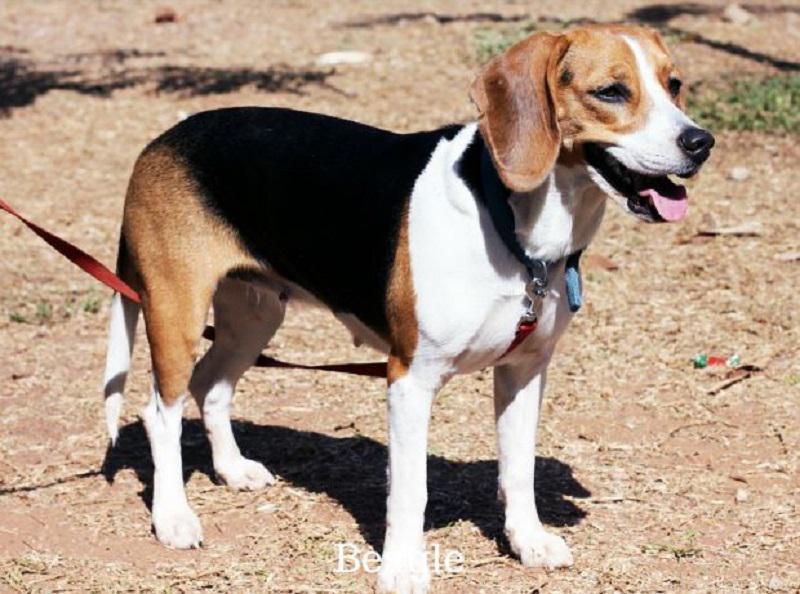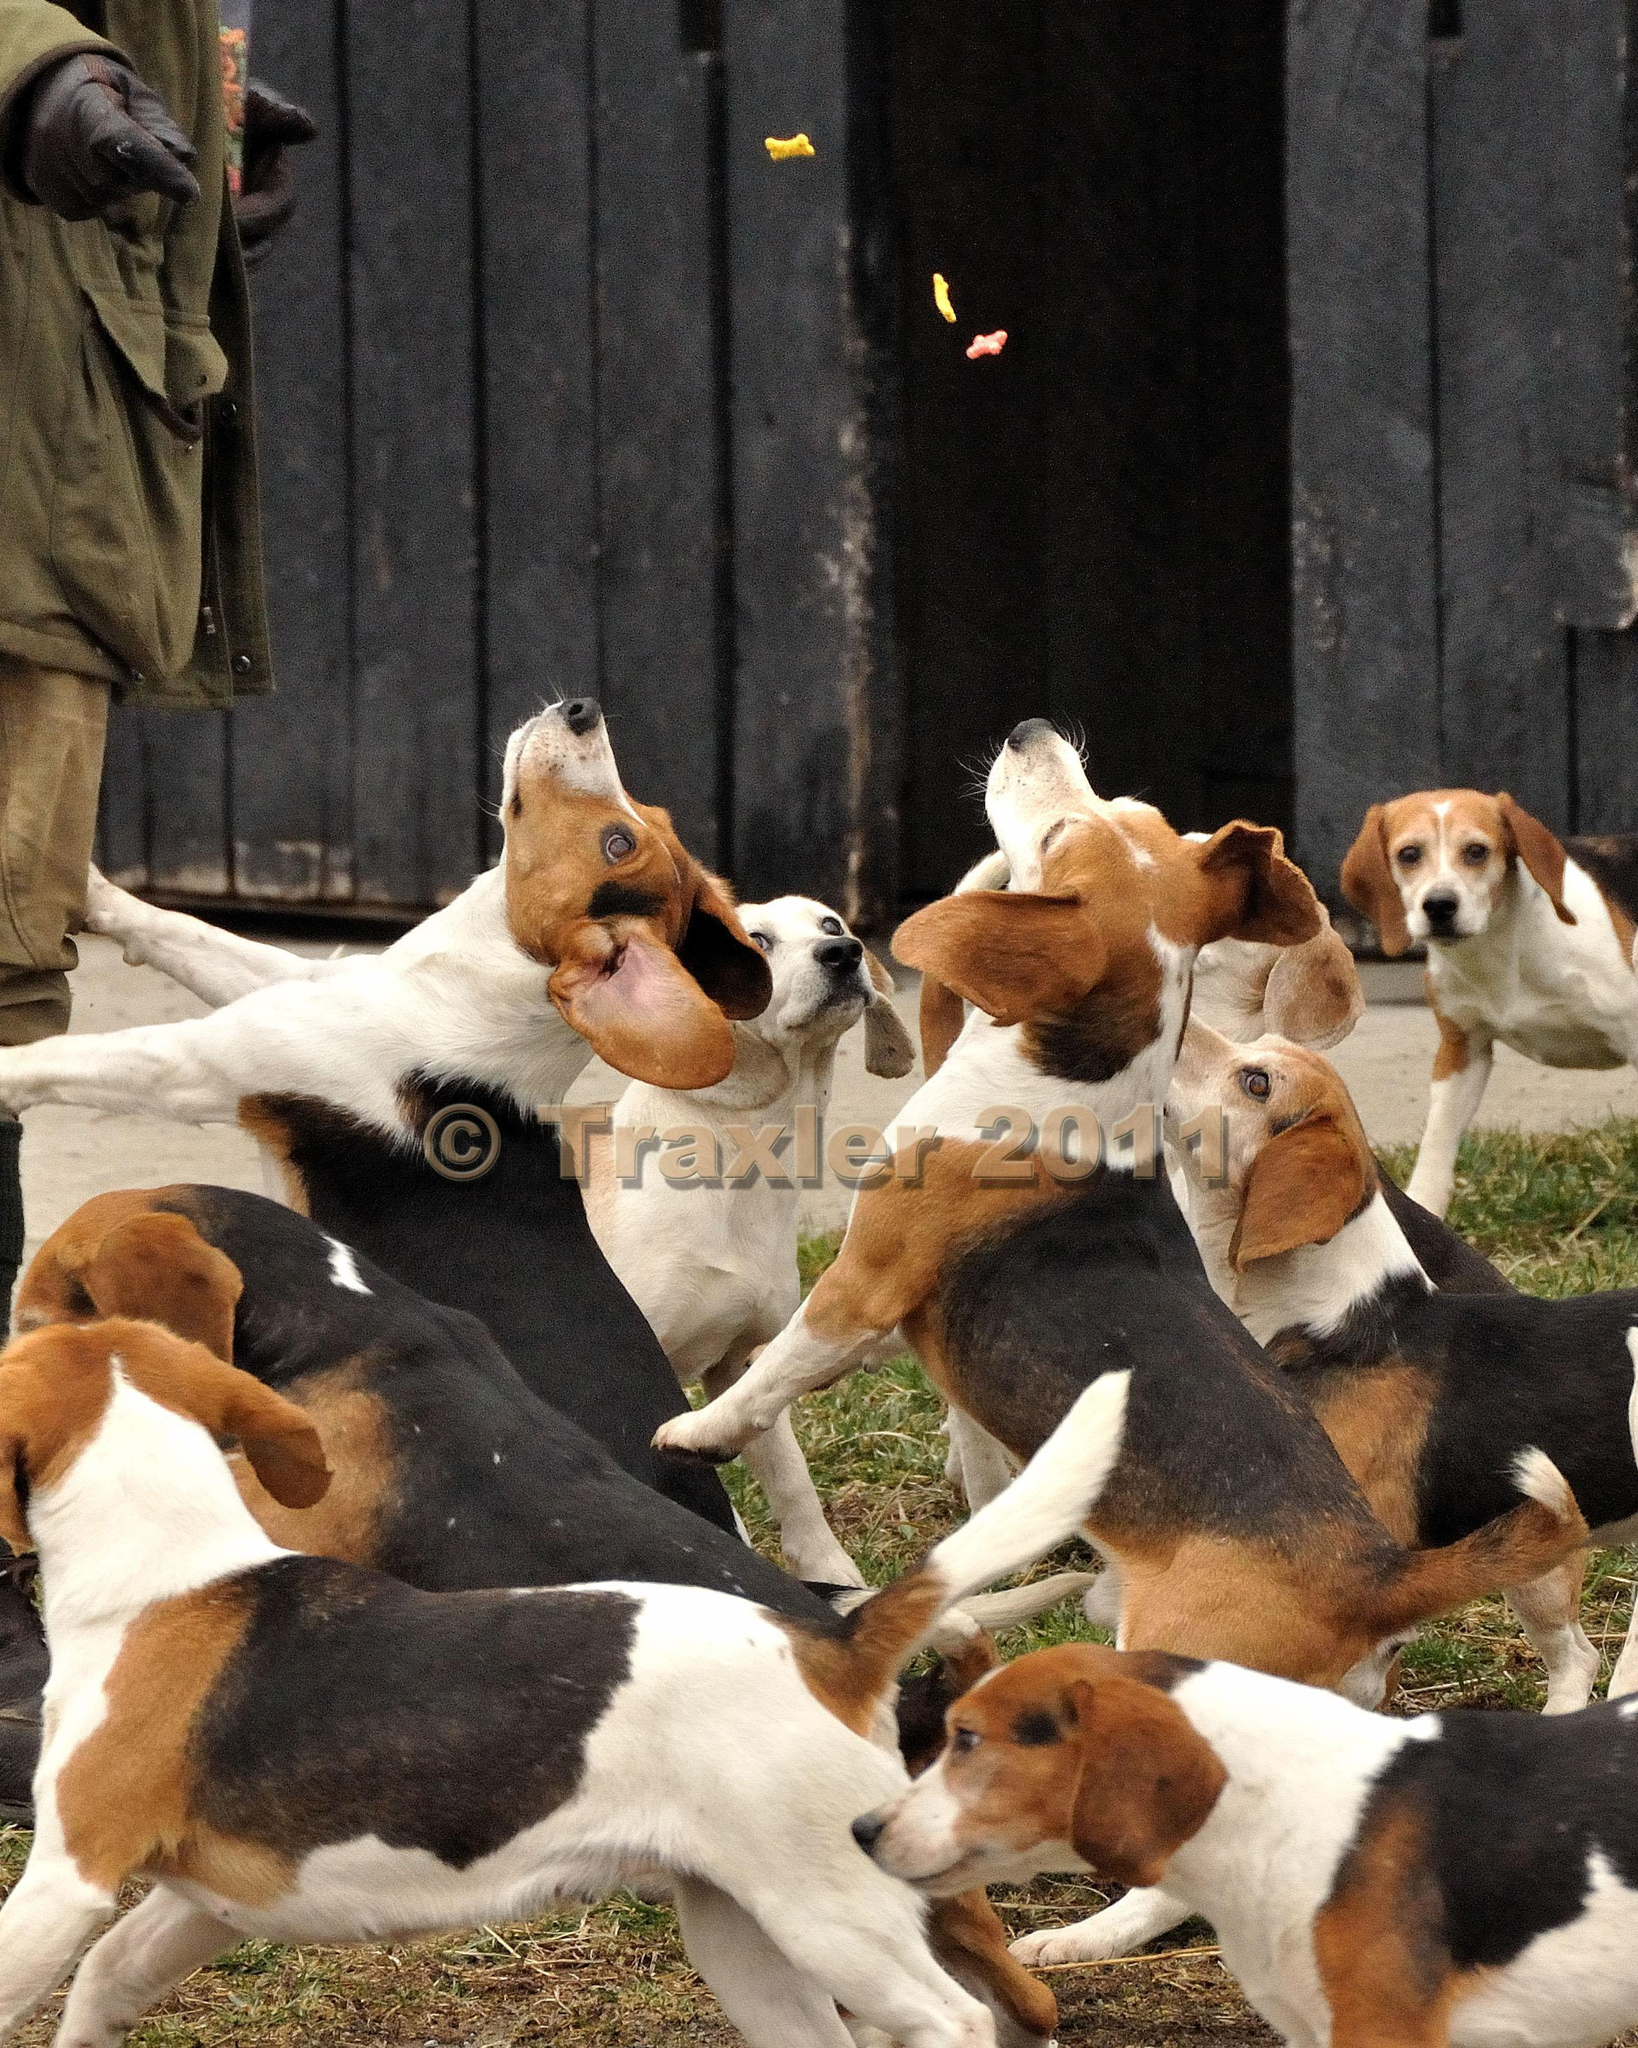The first image is the image on the left, the second image is the image on the right. Assess this claim about the two images: "A single dog is standing on the ground in the image on the right.". Correct or not? Answer yes or no. No. The first image is the image on the left, the second image is the image on the right. Considering the images on both sides, is "One image shows a beagle standing on all fours with no other being present, and the other image shows at least 8 beagles, which are not in a single row." valid? Answer yes or no. Yes. 